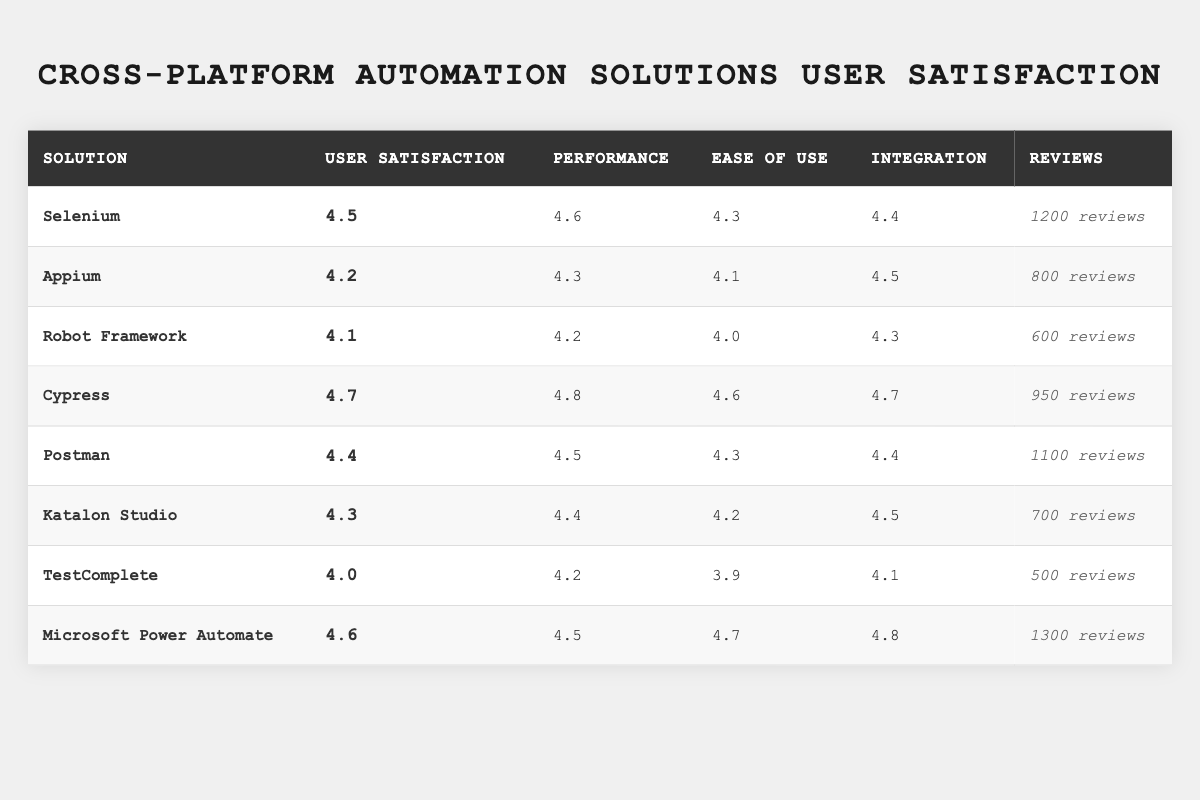What is the user satisfaction rating of Cypress? The table clearly shows that Cypress has a user satisfaction rating of 4.7, which is located in the corresponding row for this solution.
Answer: 4.7 Which solution has the highest performance rating? Looking through the performance ratings, Cypress has the highest performance rating of 4.8, more than any other listed solution.
Answer: Cypress What is the total number of reviews for all the solutions listed? By adding the number of reviews for each solution, the calculation is: 1200 + 800 + 600 + 950 + 1100 + 700 + 500 + 1300 = 5150 total reviews.
Answer: 5150 Is Katalon Studio's ease of use rating greater than its performance rating? Katalon Studio has an ease of use rating of 4.2 and a performance rating of 4.4. Since 4.2 is less than 4.4, the statement is false.
Answer: No What is the average user satisfaction rating for all the solutions? To find the average, sum the user satisfaction ratings: (4.5 + 4.2 + 4.1 + 4.7 + 4.4 + 4.3 + 4.0 + 4.6) = 34.8, and divide by the number of solutions (8): 34.8/8 = 4.35.
Answer: 4.35 Which solution has the lowest user satisfaction rating, and what is that rating? By inspecting the table, Robot Framework has the lowest user satisfaction rating of 4.1, which is lower than all other solutions listed.
Answer: Robot Framework, 4.1 Which two solutions have the same integration rating of 4.5? By examining the integration ratings, Appium and Katalon Studio both have an integration rating of 4.5.
Answer: Appium and Katalon Studio How does the performance rating of Postman compare to that of TestComplete? Postman has a performance rating of 4.5, while TestComplete has a performance rating of 4.2. Since 4.5 is greater than 4.2, Postman has a higher performance rating.
Answer: Postman is higher If you were to choose a solution based solely on user satisfaction and performance ratings, which solution would you select? Cypress has both the highest user satisfaction rating (4.7) and the highest performance rating (4.8), making it the best choice based on these criteria.
Answer: Cypress Is the ease of use rating for Microsoft Power Automate higher than the average ease of use rating of all solutions? The average ease of use rating is calculated as (4.3 + 4.1 + 4.0 + 4.6 + 4.3 + 4.2 + 3.9 + 4.7) / 8 = 4.3. Since Microsoft Power Automate has an ease of use rating of 4.7, which is higher than 4.3, the statement is true.
Answer: Yes 